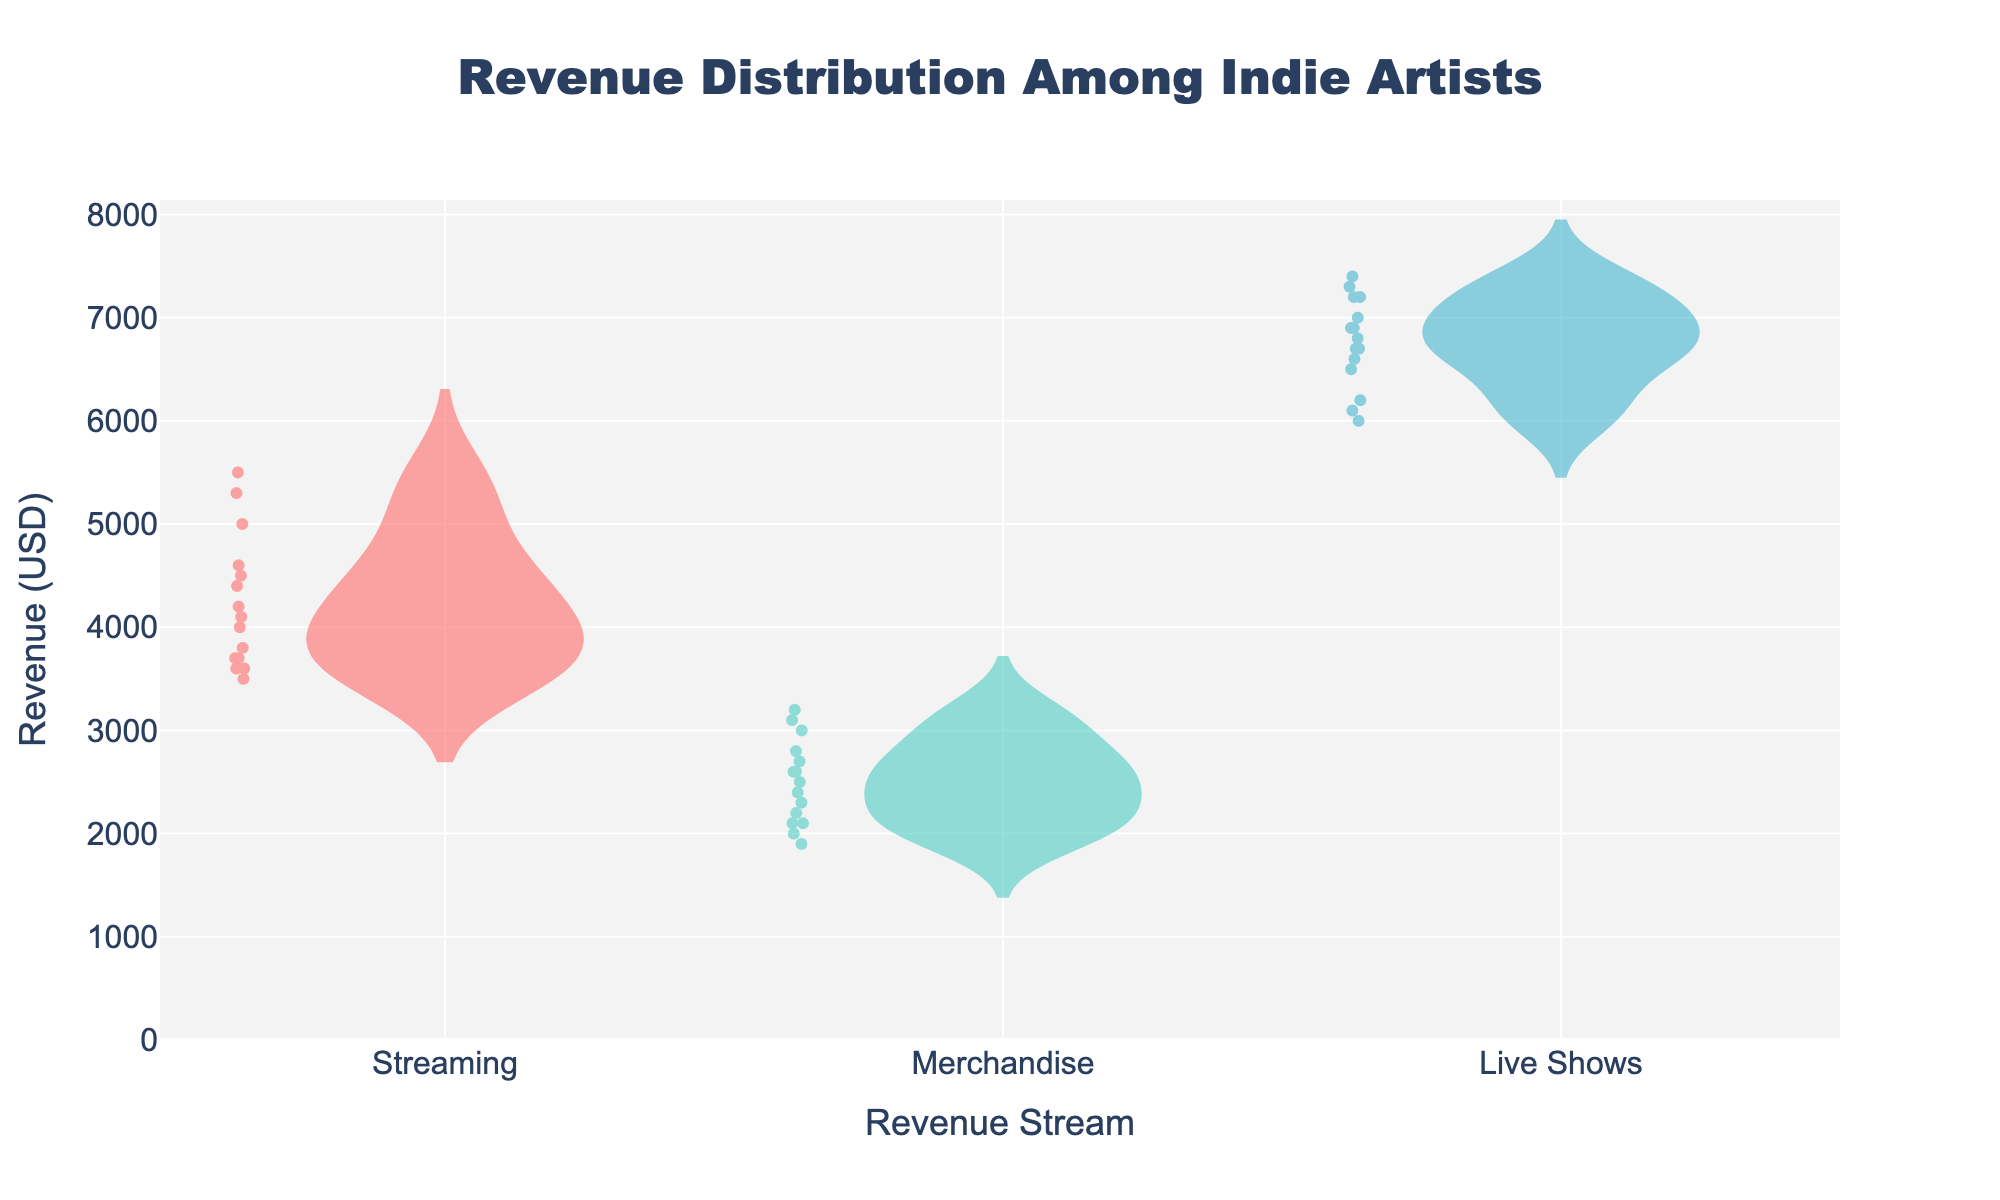What is the title of the chart? The title of the chart is written at the top center.
Answer: Revenue Distribution Among Indie Artists What are the revenue streams shown on the x-axis? The x-axis has labels for each revenue stream.
Answer: Streaming, Merchandise, Live Shows Which revenue stream has the highest median revenue? Observe the position of the horizontal mean line within each violin plot to find the highest one.
Answer: Live Shows What is the range of revenue values for the Streaming category? Identify the lowest and highest points within the Streaming violin plot.
Answer: 3500 to 5500 USD How does the spread of revenue in Merchandise compare to Streaming? Compare the width and spread of the violin plots as well as the range of data points.
Answer: Merchandise has a narrower spread than Streaming Which revenue stream appears to have the most consistent revenue across artists? Look for the smallest spread within the box plots inside the violin plots.
Answer: Merchandise What is the interquartile range (IQR) for the Live Shows category? Calculate the difference between the third quartile (Q3) and the first quartile (Q1) using the box plot in the Live Shows violin plot.
Answer: 900 USD Which revenue stream shows the most variation in revenue? Identify the violin plot with the widest spread and most scattered data points.
Answer: Streaming Which revenue stream has the lowest mean revenue? Look at the position of the mean lines across all the violin plots and identify the lowest one.
Answer: Merchandise How does the mean revenue for Streaming compare to Live Shows? Compare the mean lines within the violin plots for Streaming and Live Shows.
Answer: The mean revenue for Live Shows is higher than for Streaming 